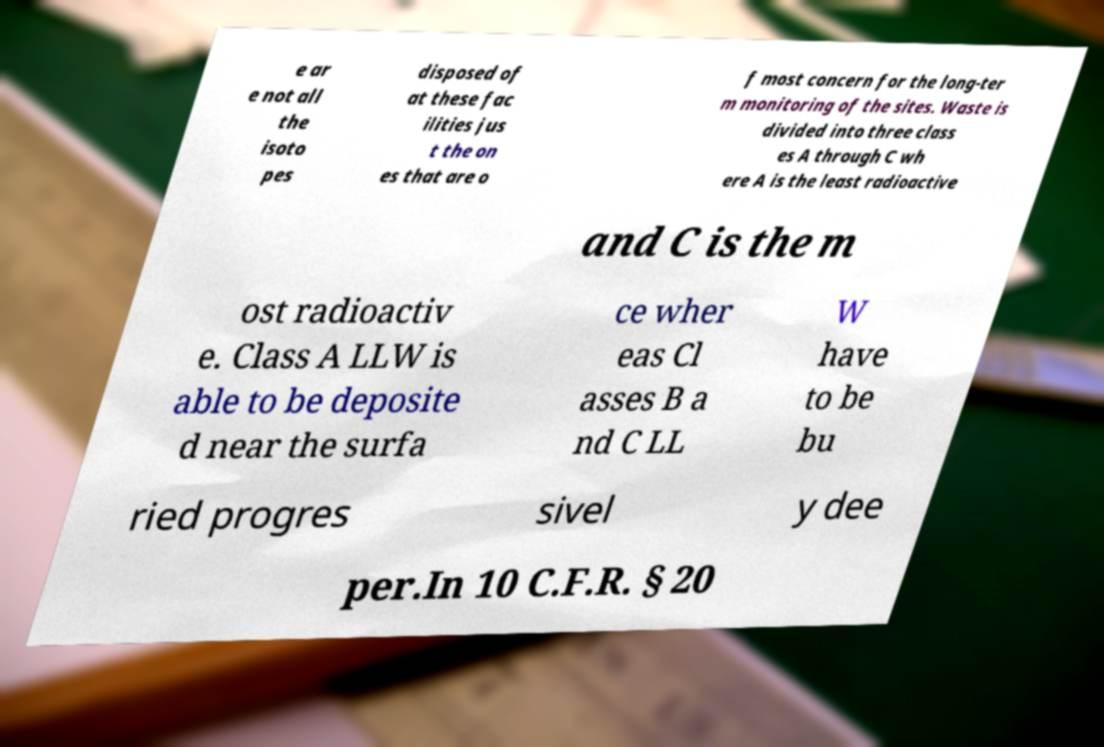What messages or text are displayed in this image? I need them in a readable, typed format. e ar e not all the isoto pes disposed of at these fac ilities jus t the on es that are o f most concern for the long-ter m monitoring of the sites. Waste is divided into three class es A through C wh ere A is the least radioactive and C is the m ost radioactiv e. Class A LLW is able to be deposite d near the surfa ce wher eas Cl asses B a nd C LL W have to be bu ried progres sivel y dee per.In 10 C.F.R. § 20 